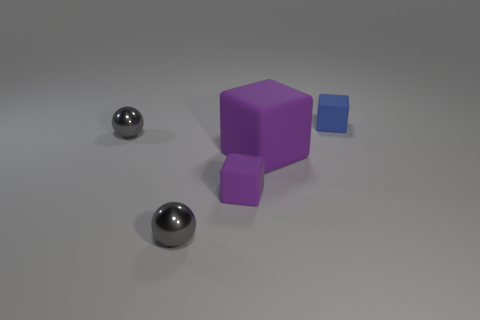Subtract all small purple matte cubes. How many cubes are left? 2 Add 3 tiny brown matte balls. How many objects exist? 8 Subtract all blue cubes. How many cubes are left? 2 Subtract all cubes. How many objects are left? 2 Subtract 2 spheres. How many spheres are left? 0 Subtract all blue cubes. Subtract all purple spheres. How many cubes are left? 2 Subtract all blue cylinders. How many red blocks are left? 0 Subtract all tiny green shiny objects. Subtract all large purple cubes. How many objects are left? 4 Add 1 purple things. How many purple things are left? 3 Add 3 large brown metal cylinders. How many large brown metal cylinders exist? 3 